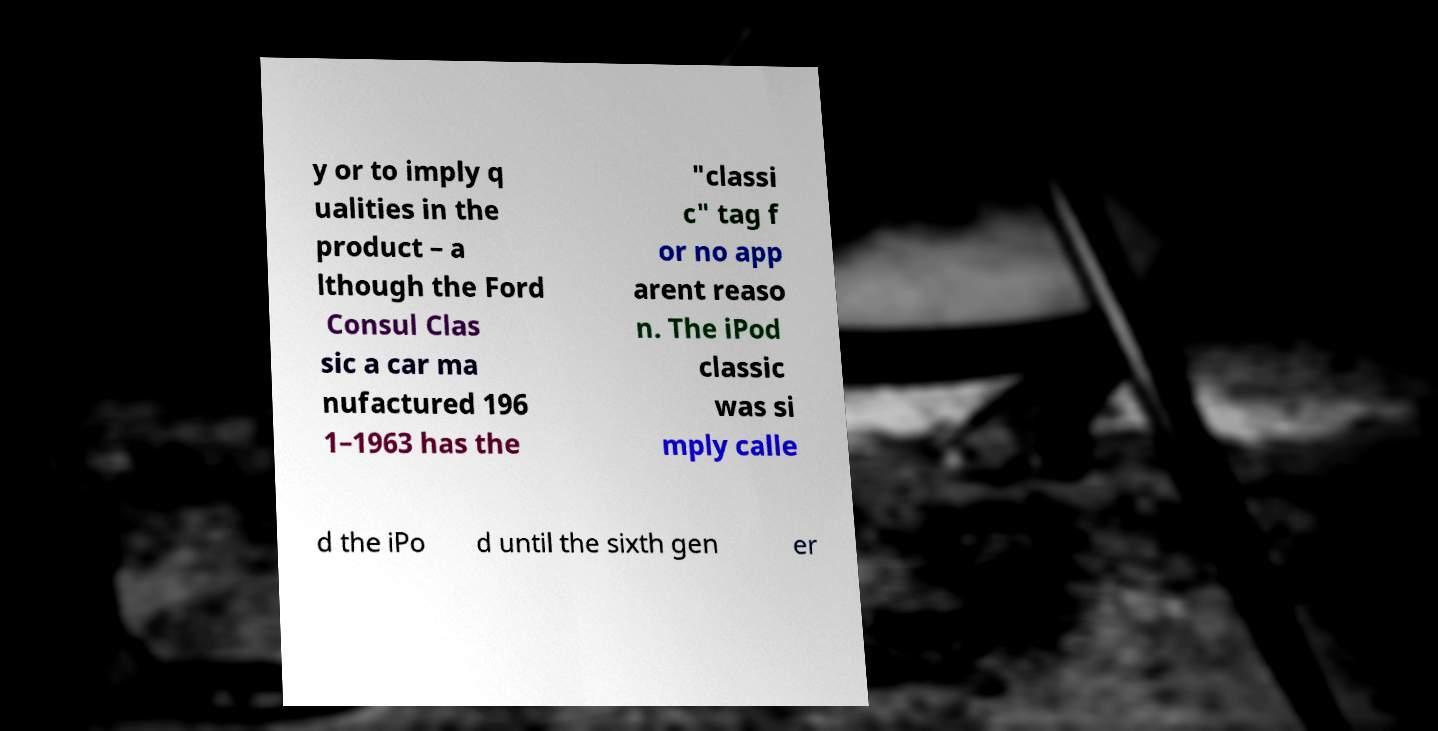There's text embedded in this image that I need extracted. Can you transcribe it verbatim? y or to imply q ualities in the product – a lthough the Ford Consul Clas sic a car ma nufactured 196 1–1963 has the "classi c" tag f or no app arent reaso n. The iPod classic was si mply calle d the iPo d until the sixth gen er 